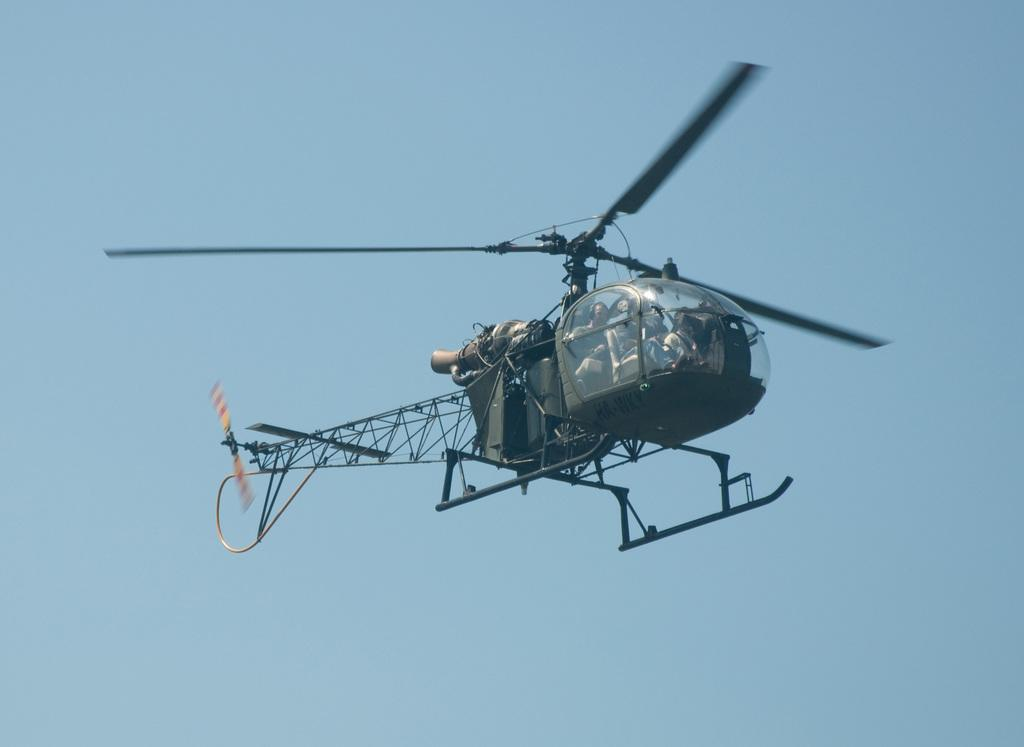What is the main subject of the image? The main subject of the image is a helicopter. What is the helicopter doing in the image? The helicopter is flying in the air. Can you tell if there is anyone inside the helicopter? Yes, there is a person inside the helicopter. What can be seen in the background of the image? The sky is visible in the background of the image. Can you see any goats on the island in the image? There is no island or goat present in the image; it features a helicopter flying in the air. What type of bird is flying alongside the helicopter in the image? There is no bird visible in the image; only the helicopter and the sky are present. 